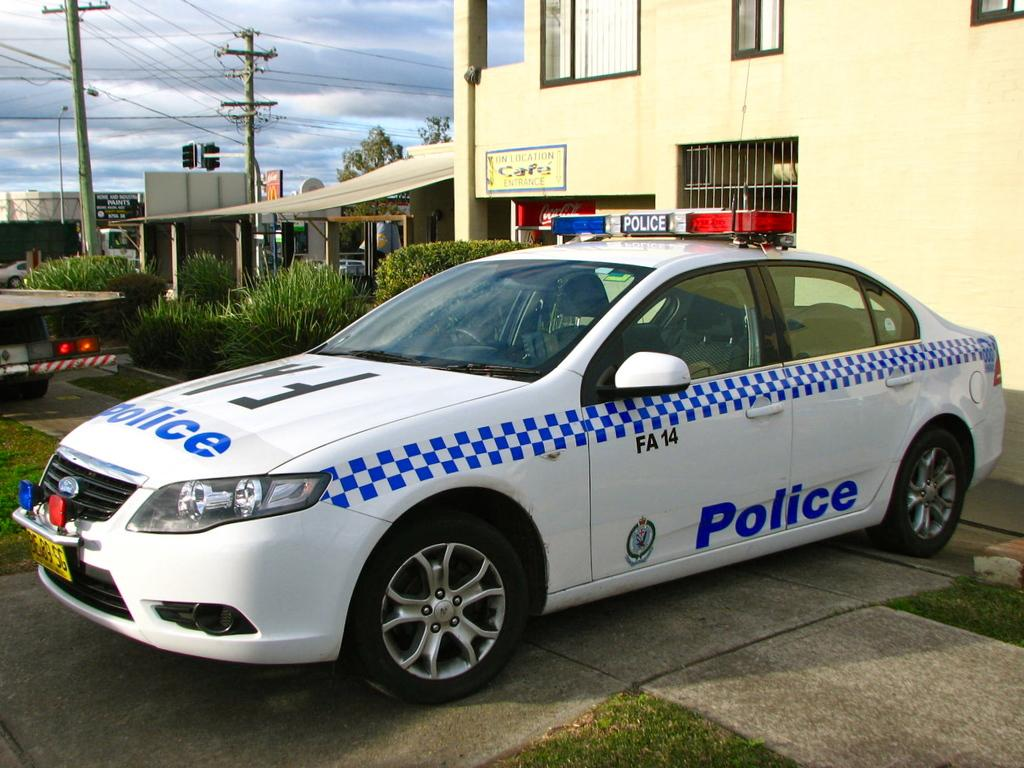What types of objects can be seen in the image? There are vehicles, boards, poles, and buildings in the image. What type of natural environment is visible in the image? There is grass, plants, trees, and the sky visible in the image. Can you describe the sky in the image? The sky is visible in the background of the image, and there are clouds present. What type of debt is being discussed in the image? There is no mention of debt in the image; it features vehicles, grass, plants, boards, poles, trees, buildings, and a sky with clouds. How much zinc can be seen in the image? There is no zinc present in the image. 